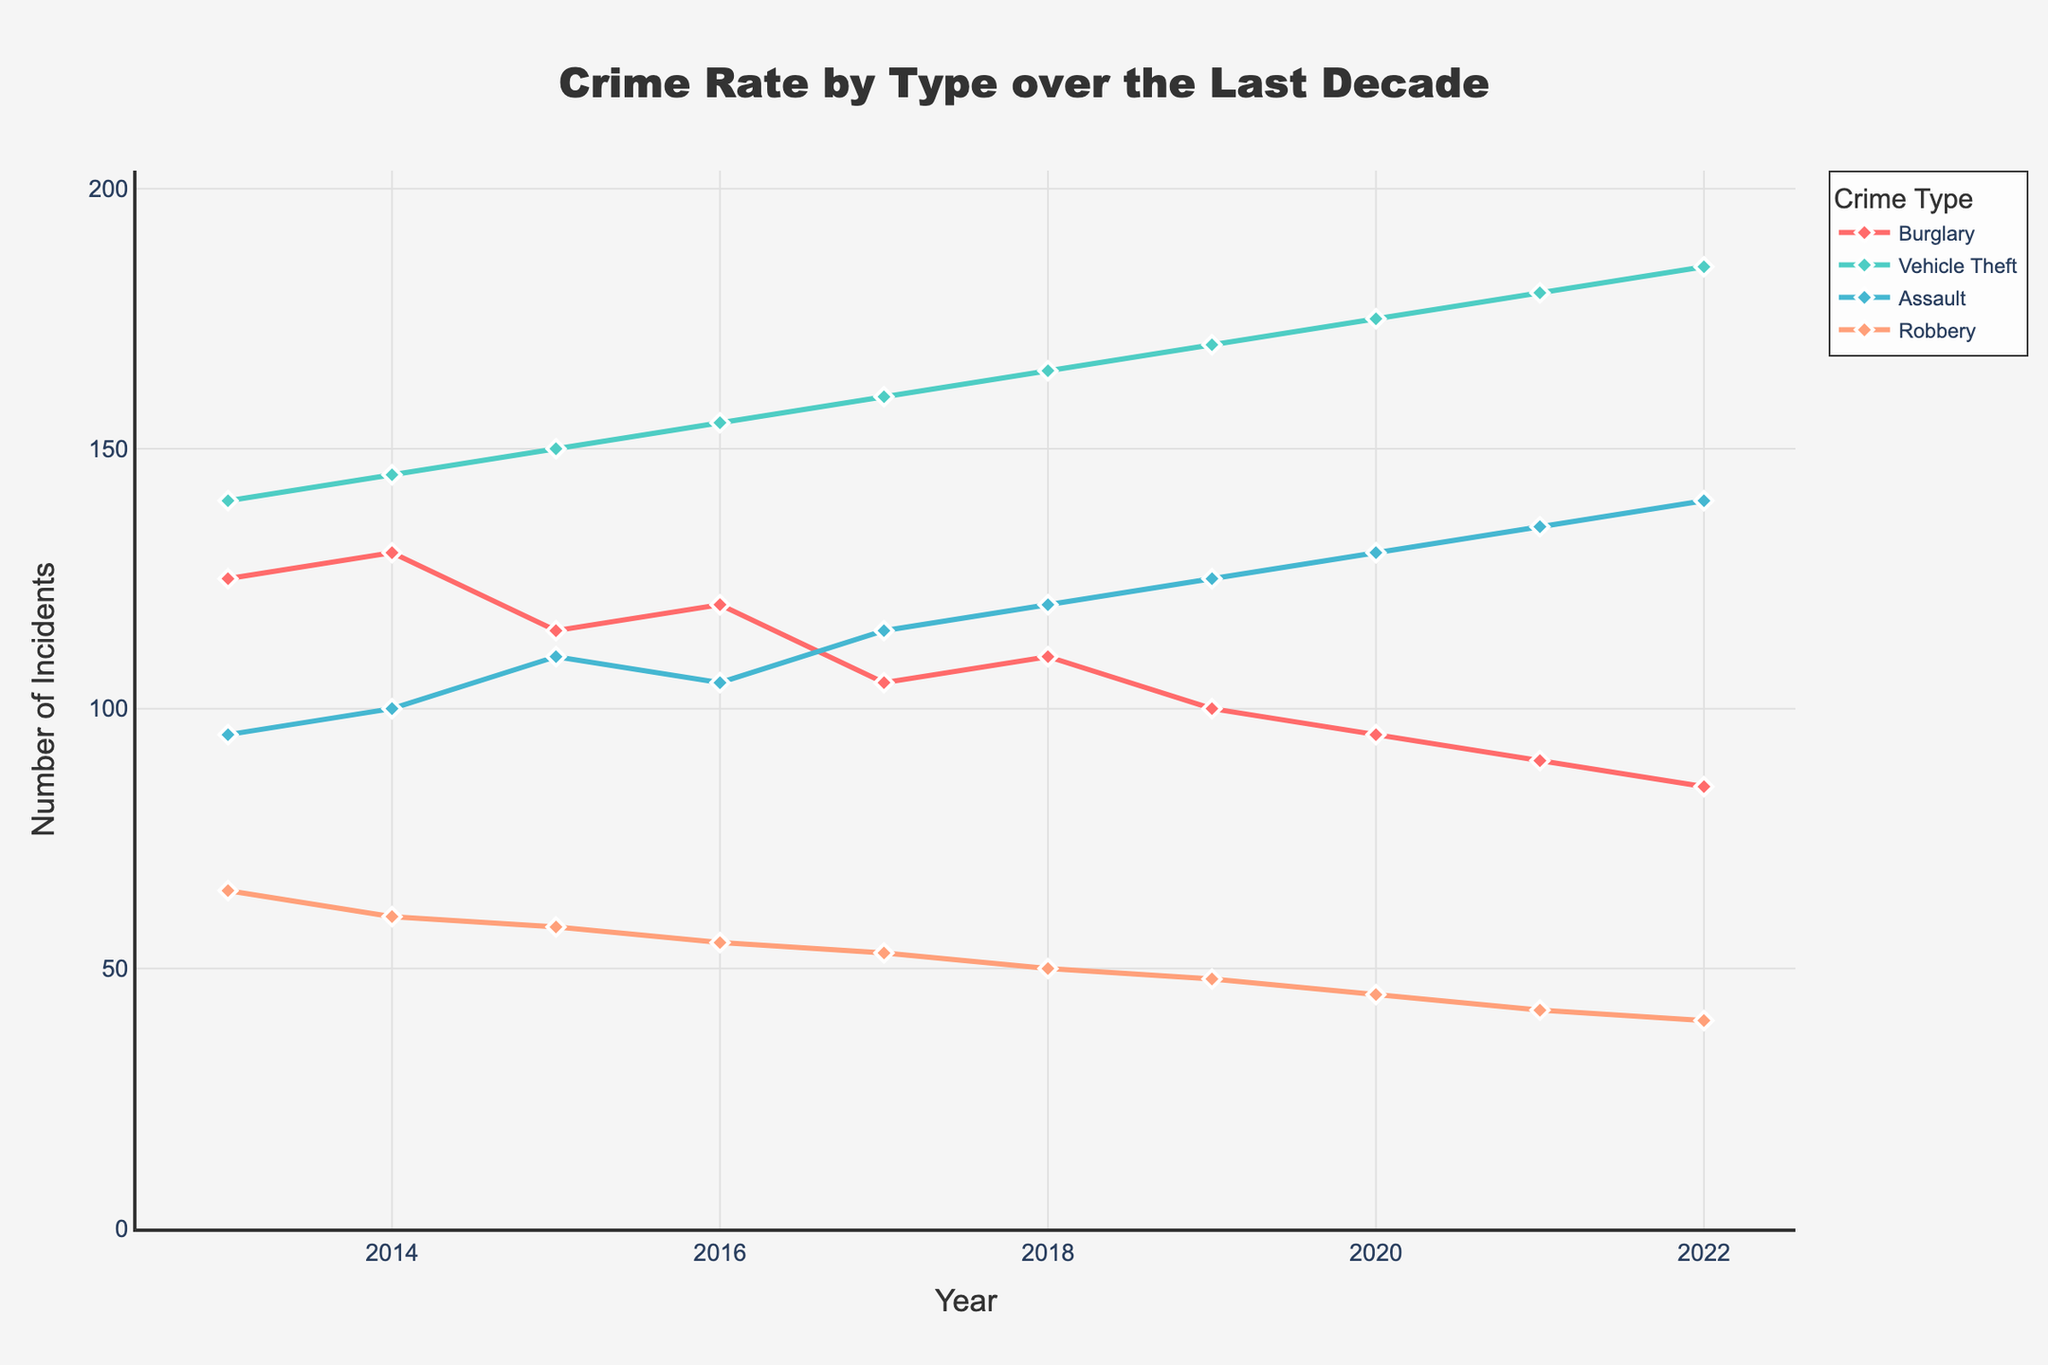what is the title of the figure? The title of the figure is generally placed at the top and is intended to give a brief idea about the content of the plot. In this case, the title is "Crime Rate by Type over the Last Decade".
Answer: Crime Rate by Type over the Last Decade What is the crime type with the highest number of incidents in 2022? To find the crime type with the highest number of incidents in 2022, look at the 2022 data points across all crime types and compare their values. Vehicle Theft has the highest number of incidents in 2022.
Answer: Vehicle Theft Which year saw the highest number of burglaries? To determine the year with the highest burglaries, follow the Burglary line plot and identify the peak value across the years. The peak for Burglary is in 2014.
Answer: 2014 How did the number of assault incidents change from 2013 to 2022? To assess the change in the number of assault incidents, compare the values at the start (2013) and end (2022) of the time series for the Assault data points. In 2013, there were 95 incidents, and in 2022, there were 140 incidents.
Answer: Increased by 45 What is the general trend for vehicle theft over the last decade? Examine the line representing Vehicle Theft from 2013 to 2022. The line generally increases, indicating a rising trend.
Answer: Increasing Which crime type had the most stable incident rate over the decade? Look for the crime type whose line plot shows the least fluctuation over the years. The Robbery line remains the most stable with slight decreases each year.
Answer: Robbery What is the combined number of incidents for all crime types in 2016? Sum the number of incidents for each crime type in 2016: Burglary (120) + Vehicle Theft (155) + Assault (105) + Robbery (55). The combined number is 435.
Answer: 435 In what year did Robbery incidents dip below 50? Find the point on the Robbery line where it goes below the 50-incident mark. This first occurs in 2018 with 50 incidents and consistently below afterward.
Answer: 2018 How many crime types had their highest incidents in 2022? For each crime type, check their incidents across the decade. Compare and find which ones peak in 2022. Only Vehicle Theft and Assault peak in 2022.
Answer: 2 What was the percentage increase in vehicle theft incidents from 2013 to 2022? First find the number of vehicle theft incidents in 2013 (140) and in 2022 (185). Calculate the percentage increase: [(185 - 140)/140] * 100. The increase is 32.14%.
Answer: 32.14% Which years saw less than 100 burglary incidents? Look at the Burglary line plot and identify years when the data point is below 100. These years are 2019, 2020, 2021, and 2022.
Answer: 2019, 2020, 2021, 2022 